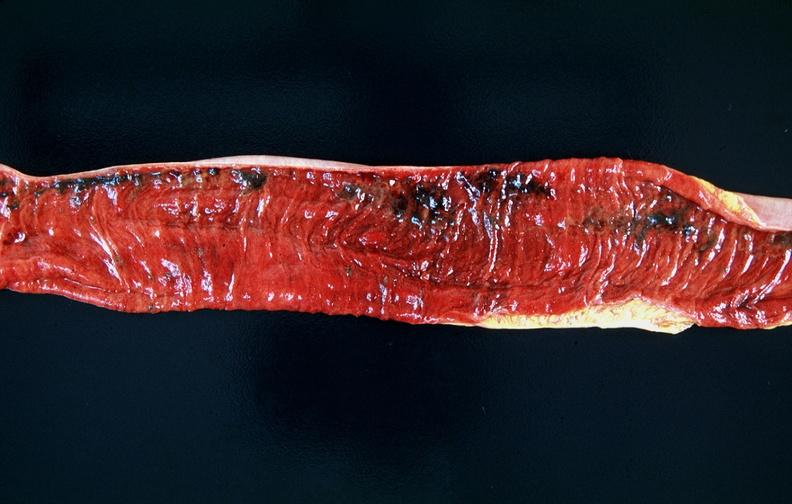where does this belong to?
Answer the question using a single word or phrase. Gastrointestinal system 